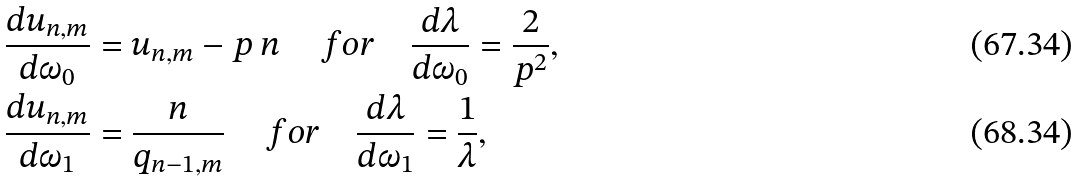Convert formula to latex. <formula><loc_0><loc_0><loc_500><loc_500>& \frac { d u _ { n , m } } { d \omega _ { 0 } } = u _ { n , m } - p \, n \quad \, f o r \quad \frac { d \lambda } { d \omega _ { 0 } } = \frac { 2 } { p ^ { 2 } } , \\ & \frac { d u _ { n , m } } { d \omega _ { 1 } } = \frac { n } { q _ { n - 1 , m } } \, \quad f o r \quad \frac { d \lambda } { d \omega _ { 1 } } = \frac { 1 } { \lambda } ,</formula> 